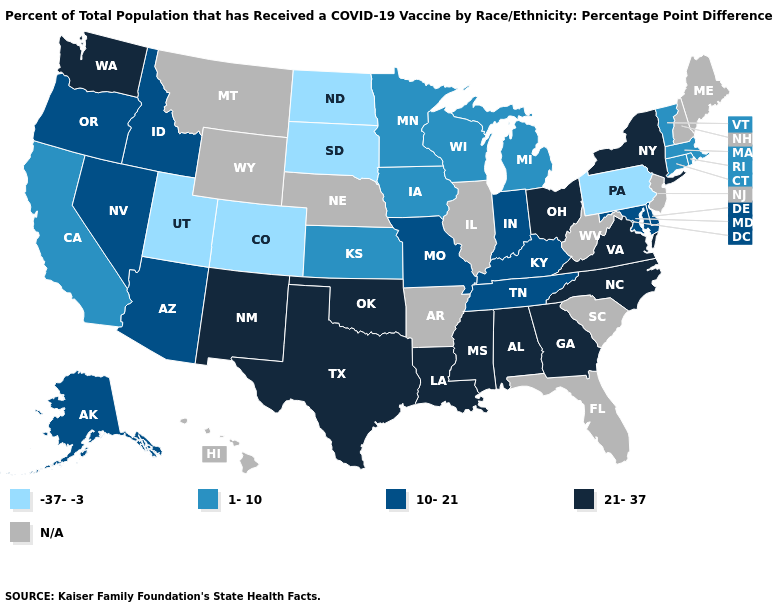What is the lowest value in states that border Connecticut?
Keep it brief. 1-10. What is the value of Oklahoma?
Keep it brief. 21-37. What is the value of Illinois?
Give a very brief answer. N/A. What is the highest value in the MidWest ?
Concise answer only. 21-37. What is the lowest value in states that border Oregon?
Concise answer only. 1-10. Which states hav the highest value in the South?
Concise answer only. Alabama, Georgia, Louisiana, Mississippi, North Carolina, Oklahoma, Texas, Virginia. What is the highest value in the MidWest ?
Write a very short answer. 21-37. Among the states that border Montana , which have the highest value?
Concise answer only. Idaho. Name the states that have a value in the range 10-21?
Concise answer only. Alaska, Arizona, Delaware, Idaho, Indiana, Kentucky, Maryland, Missouri, Nevada, Oregon, Tennessee. Which states have the lowest value in the Northeast?
Quick response, please. Pennsylvania. Among the states that border West Virginia , does Ohio have the highest value?
Quick response, please. Yes. Which states have the lowest value in the USA?
Concise answer only. Colorado, North Dakota, Pennsylvania, South Dakota, Utah. What is the lowest value in states that border Nebraska?
Quick response, please. -37--3. Does the map have missing data?
Quick response, please. Yes. 